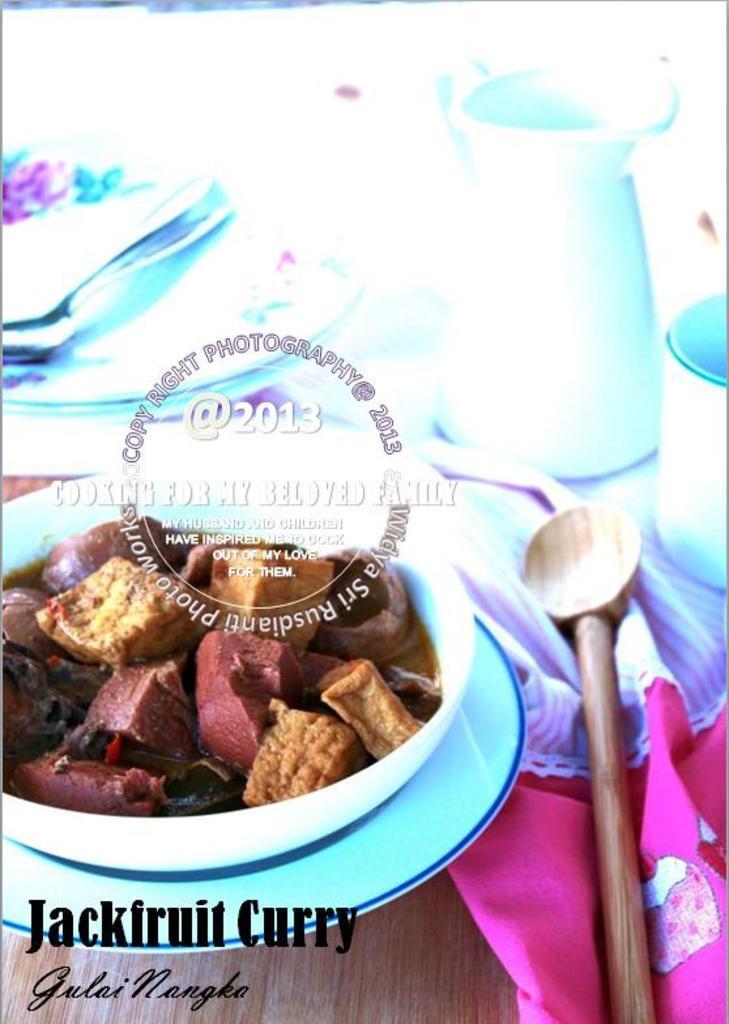How would you summarize this image in a sentence or two? In this image I can see the plate with color. The food is in brown and red color. To the side I can see the wooden spoon and cloth. These are on the brown color table. And there is a white background. 